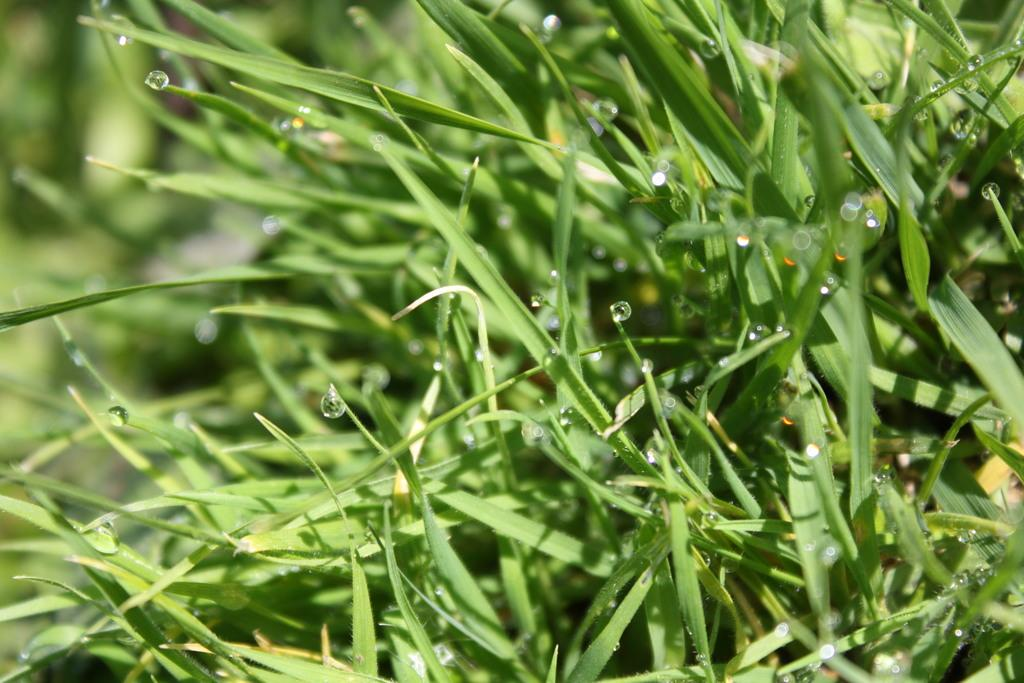What can be seen on the grass in the image? There are water drops on the grass in the image. Can you describe the background of the image? The background of the image is blurred. Where is the jar placed in the image? There is no jar present in the image. What type of throne can be seen in the image? There is no throne present in the image. 